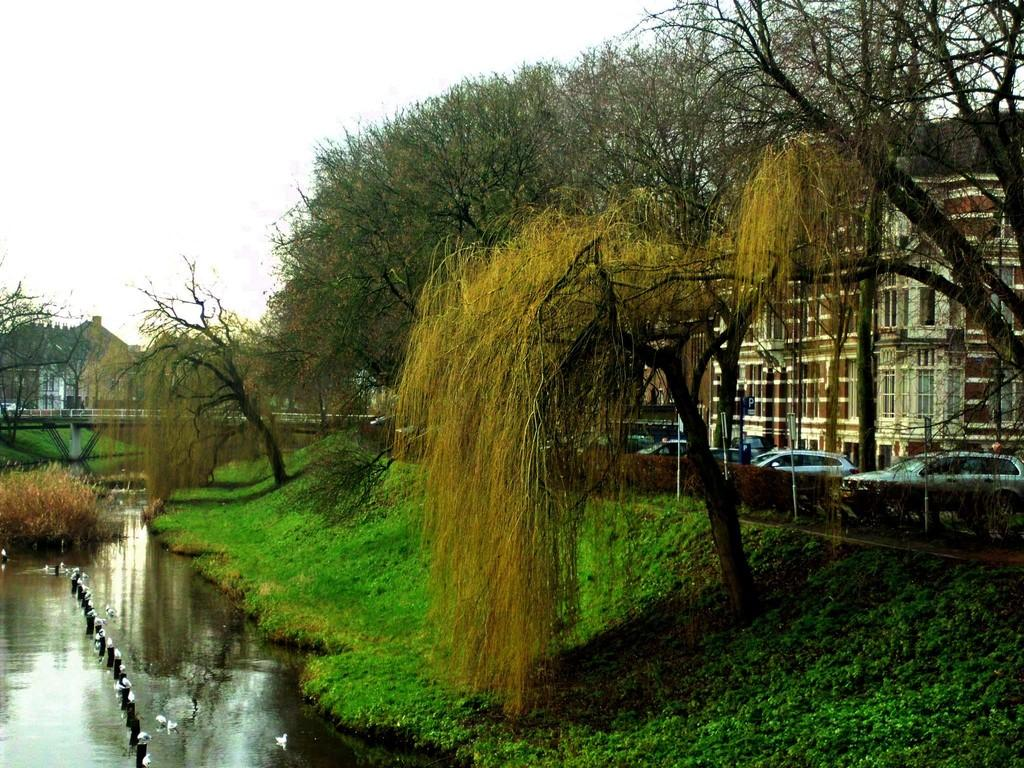What type of structures can be seen in the image? There are buildings in the image. What type of vegetation is present in the image? There are trees and grass visible in the image. What type of transportation is present on the road in the image? Motor vehicles are present on the road in the image. What type of animals can be seen in the image? Birds are present in the image. What type of safety feature is present on the road in the image? Barrier poles are in the image. What type of man-made structure is present over the river in the image? There is a bridge over a river in the image. What type of natural feature is visible in the image? Hills are visible in the image. What part of the natural environment is visible in the image? The sky is visible in the image. Where are the cherries being used in the image? There are no cherries present in the image. What type of sport is being played on the bridge in the image? There is no sport being played in the image, and the bridge is not a location for playing sports. What type of jewelry is being worn by the birds in the image? There are no birds wearing jewelry in the image; the birds are simply present in the image. 